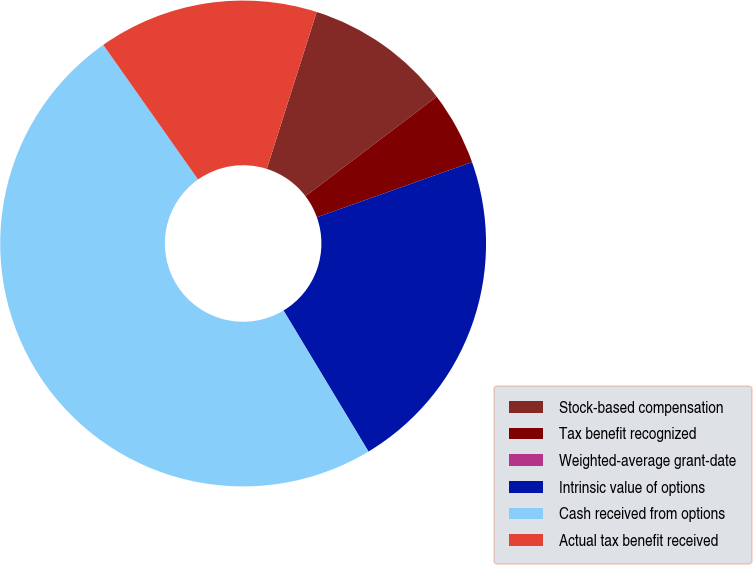Convert chart to OTSL. <chart><loc_0><loc_0><loc_500><loc_500><pie_chart><fcel>Stock-based compensation<fcel>Tax benefit recognized<fcel>Weighted-average grant-date<fcel>Intrinsic value of options<fcel>Cash received from options<fcel>Actual tax benefit received<nl><fcel>9.78%<fcel>4.89%<fcel>0.0%<fcel>21.81%<fcel>48.87%<fcel>14.66%<nl></chart> 